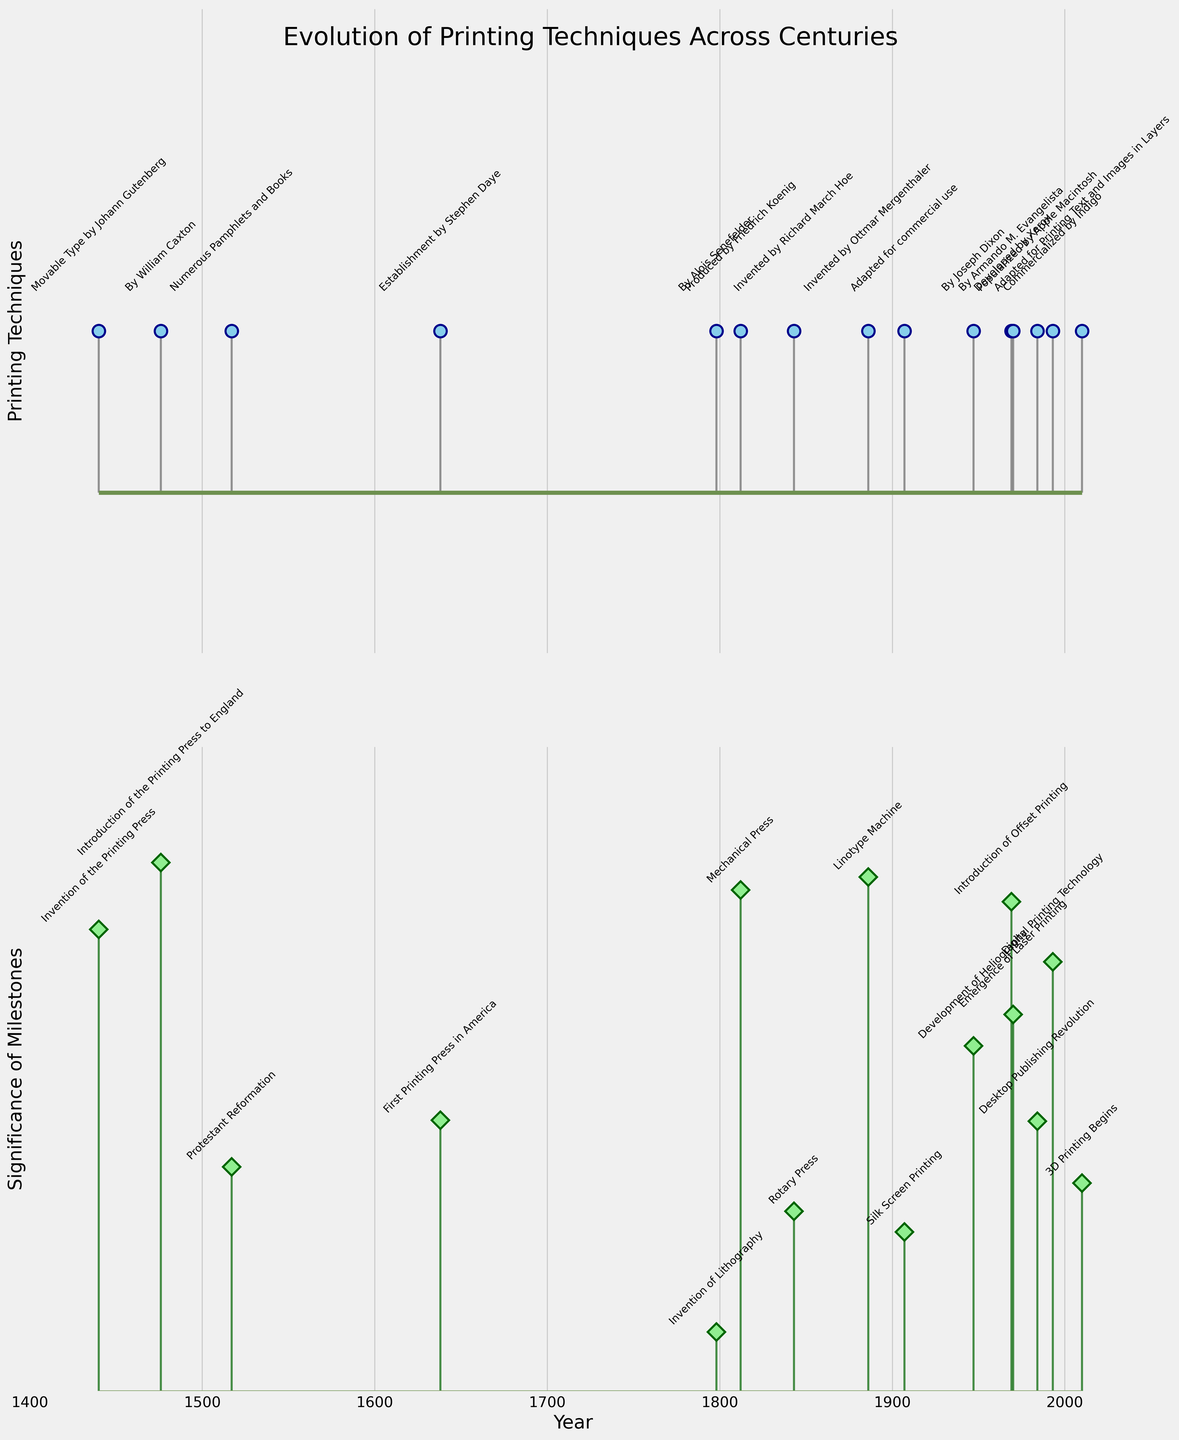What is the title of the figure? The title is located at the top of the figure, providing a summary of what the figure represents. Reading this text gives insight into the main subject of the figure.
Answer: Evolution of Printing Techniques Across Centuries How many milestones are depicted in the second subplot? Count the markers or data points in the second subplot to determine the total number of milestones. These are represented by the 'D' shaped markers along the stem plot.
Answer: 15 Which printing technique was introduced in the year 1843? Look at the first subplot and locate the year 1843 on the x-axis. Trace vertically to find the annotation of the printing technique at that point.
Answer: Rotary Press Between which years does the figure span? Check the x-axis to see the range of years. Specifically, look at the minimum and maximum values labeled on the x-axis.
Answer: 1440 to 2010 What is the general trend in the significance of milestones over time? Observe the second subplot, looking at how the 'significance' values change as you move from left (earlier years) to right (later years). Assess whether it increases, decreases, or remains stable.
Answer: Increases Which milestone corresponds to the year 1984? In the second subplot, locate the year 1984 on the x-axis and find the annotation at that point.
Answer: Desktop Publishing Revolution Which printing technique is associated with the highest significance value? Identify the highest stem in the second subplot and trace back to see which printing technique corresponds to it from the first subplot by matching the year.
Answer: 3D Printing Begins How does the significance of the milestone in 1886 compare to the significance of the milestone in 1798? Look at the significance values (vertical height of the stems) for the years 1886 and 1798 in the second subplot and compare their heights.
Answer: Higher in 1886 Which technique revolutionized book production and literacy rates, and when was it invented? Look for the milestone with the description that mentions revolutionizing book production and literacy rates in the figure and note the associated technique and year from the annotations.
Answer: Movable Type by Johann Gutenberg, 1440 